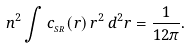Convert formula to latex. <formula><loc_0><loc_0><loc_500><loc_500>n ^ { 2 } \int c _ { _ { S R } } ( r ) \, r ^ { 2 } \, d ^ { 2 } { r } = \frac { 1 } { 1 2 \pi } .</formula> 